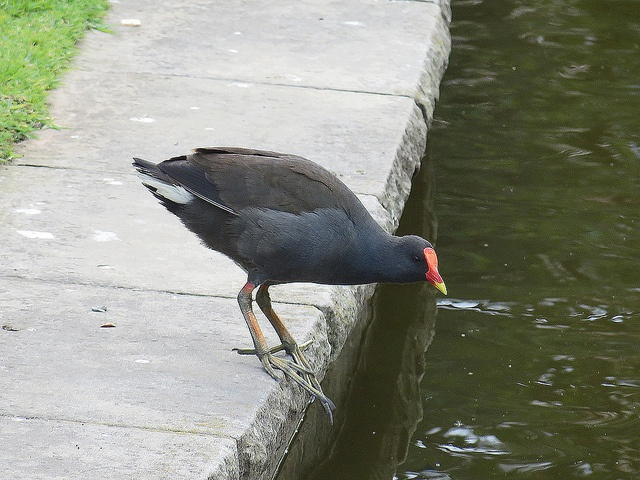Describe the objects in this image and their specific colors. I can see a bird in lightgreen, gray, black, and darkgray tones in this image. 